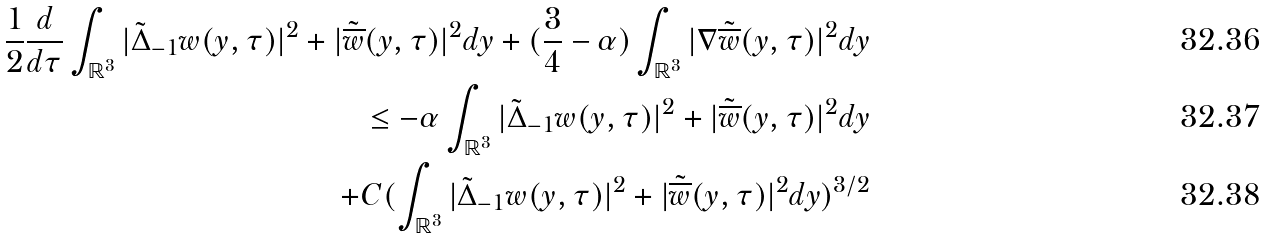<formula> <loc_0><loc_0><loc_500><loc_500>\frac { 1 } { 2 } \frac { d } { d \tau } \int _ { \mathbb { R } ^ { 3 } } | \tilde { \Delta } _ { - 1 } w ( y , \tau ) | ^ { 2 } + | \tilde { \overline { w } } ( y , \tau ) | ^ { 2 } d y + ( \frac { 3 } { 4 } - \alpha ) \int _ { \mathbb { R } ^ { 3 } } | \nabla \tilde { \overline { w } } ( y , \tau ) | ^ { 2 } d y \\ \leq - \alpha \int _ { \mathbb { R } ^ { 3 } } | \tilde { \Delta } _ { - 1 } w ( y , \tau ) | ^ { 2 } + | \tilde { \overline { w } } ( y , \tau ) | ^ { 2 } d y \\ + C ( \int _ { \mathbb { R } ^ { 3 } } | \tilde { \Delta } _ { - 1 } w ( y , \tau ) | ^ { 2 } + | \tilde { \overline { w } } ( y , \tau ) | ^ { 2 } d y ) ^ { 3 / 2 }</formula> 